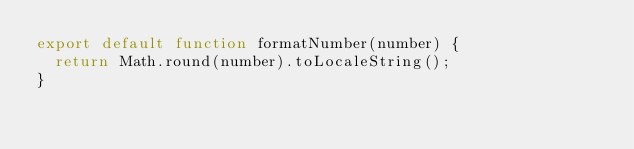Convert code to text. <code><loc_0><loc_0><loc_500><loc_500><_JavaScript_>export default function formatNumber(number) {
  return Math.round(number).toLocaleString();
}
</code> 